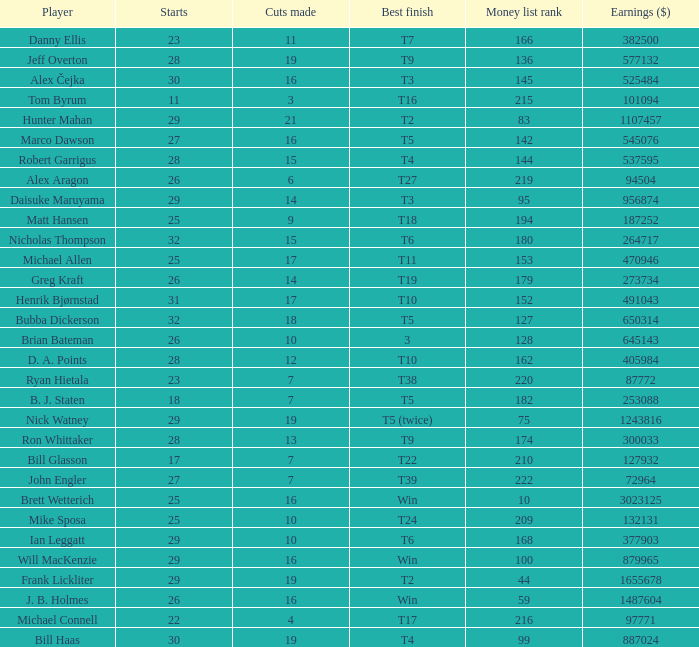What is the minimum number of cuts made for Hunter Mahan? 21.0. 